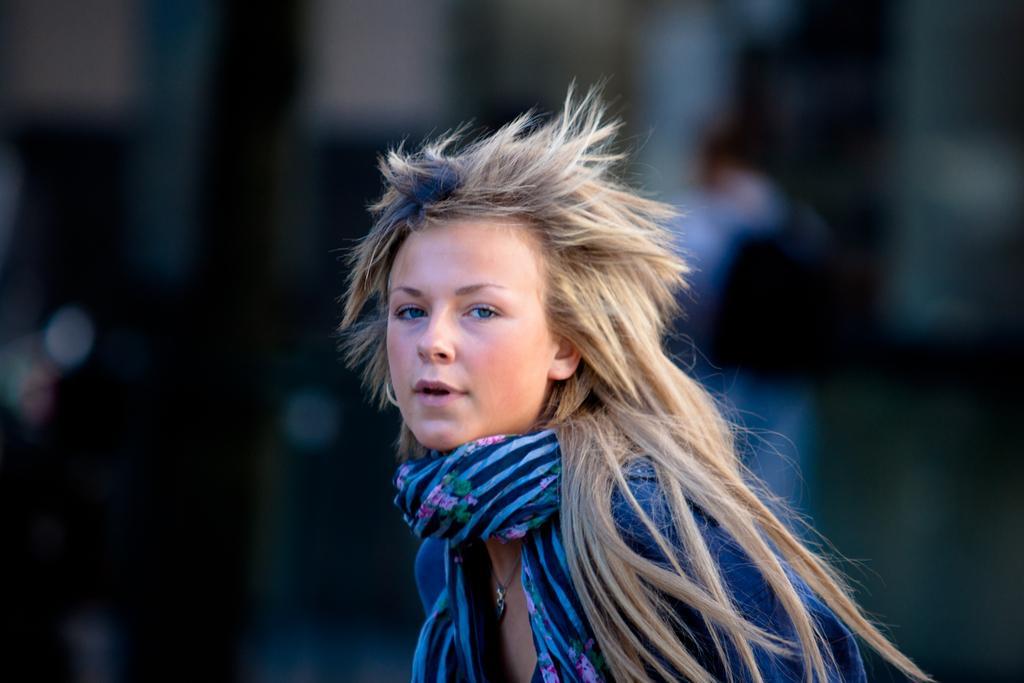Please provide a concise description of this image. In this image we can see a lady and the background is blurry. 